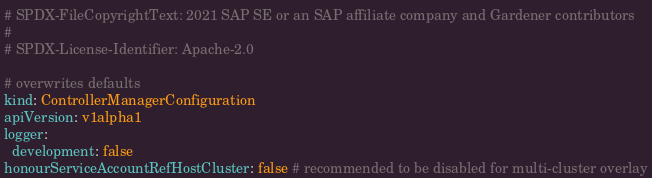<code> <loc_0><loc_0><loc_500><loc_500><_YAML_># SPDX-FileCopyrightText: 2021 SAP SE or an SAP affiliate company and Gardener contributors
#
# SPDX-License-Identifier: Apache-2.0

# overwrites defaults
kind: ControllerManagerConfiguration
apiVersion: v1alpha1
logger:
  development: false
honourServiceAccountRefHostCluster: false # recommended to be disabled for multi-cluster overlay
</code> 